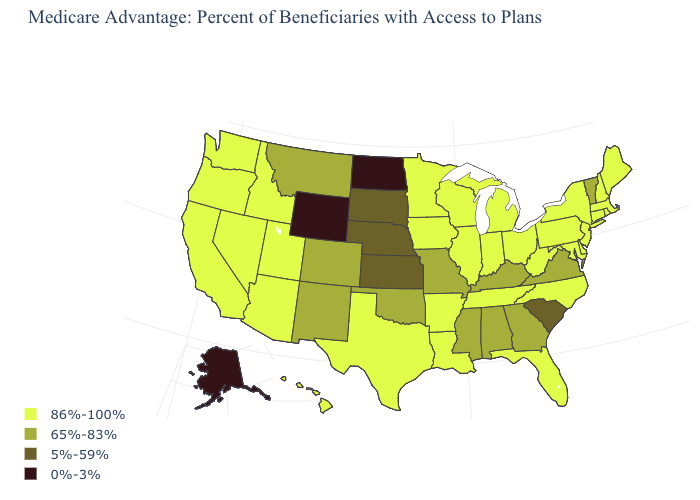What is the value of Virginia?
Quick response, please. 65%-83%. Does the map have missing data?
Keep it brief. No. Does the map have missing data?
Keep it brief. No. Which states have the lowest value in the MidWest?
Keep it brief. North Dakota. What is the highest value in states that border Rhode Island?
Short answer required. 86%-100%. Which states have the lowest value in the West?
Write a very short answer. Alaska, Wyoming. What is the highest value in states that border Iowa?
Quick response, please. 86%-100%. Does South Dakota have the highest value in the USA?
Keep it brief. No. Is the legend a continuous bar?
Concise answer only. No. Does Minnesota have the highest value in the USA?
Answer briefly. Yes. What is the highest value in states that border Louisiana?
Give a very brief answer. 86%-100%. Name the states that have a value in the range 5%-59%?
Keep it brief. Kansas, Nebraska, South Carolina, South Dakota. Does Indiana have the same value as New Jersey?
Give a very brief answer. Yes. What is the value of New Jersey?
Write a very short answer. 86%-100%. 